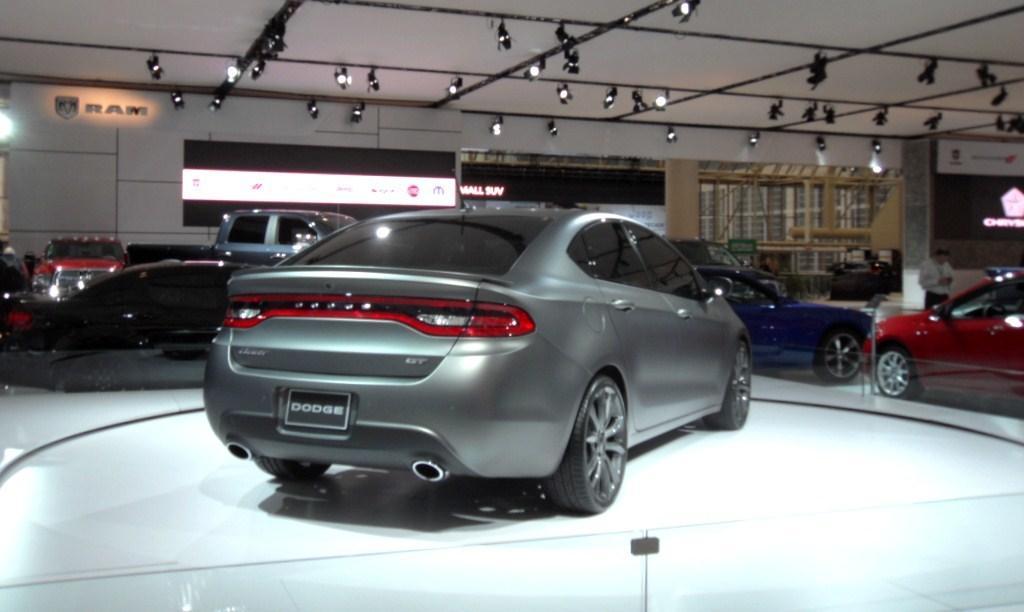In one or two sentences, can you explain what this image depicts? Here we can see vehicles and persons. These are lights. 